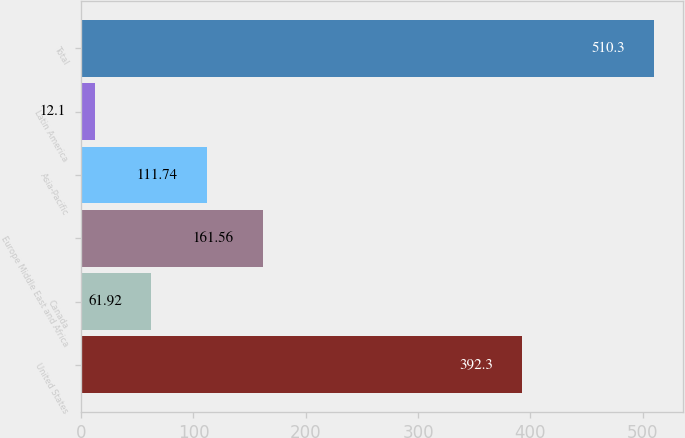<chart> <loc_0><loc_0><loc_500><loc_500><bar_chart><fcel>United States<fcel>Canada<fcel>Europe Middle East and Africa<fcel>Asia-Pacific<fcel>Latin America<fcel>Total<nl><fcel>392.3<fcel>61.92<fcel>161.56<fcel>111.74<fcel>12.1<fcel>510.3<nl></chart> 